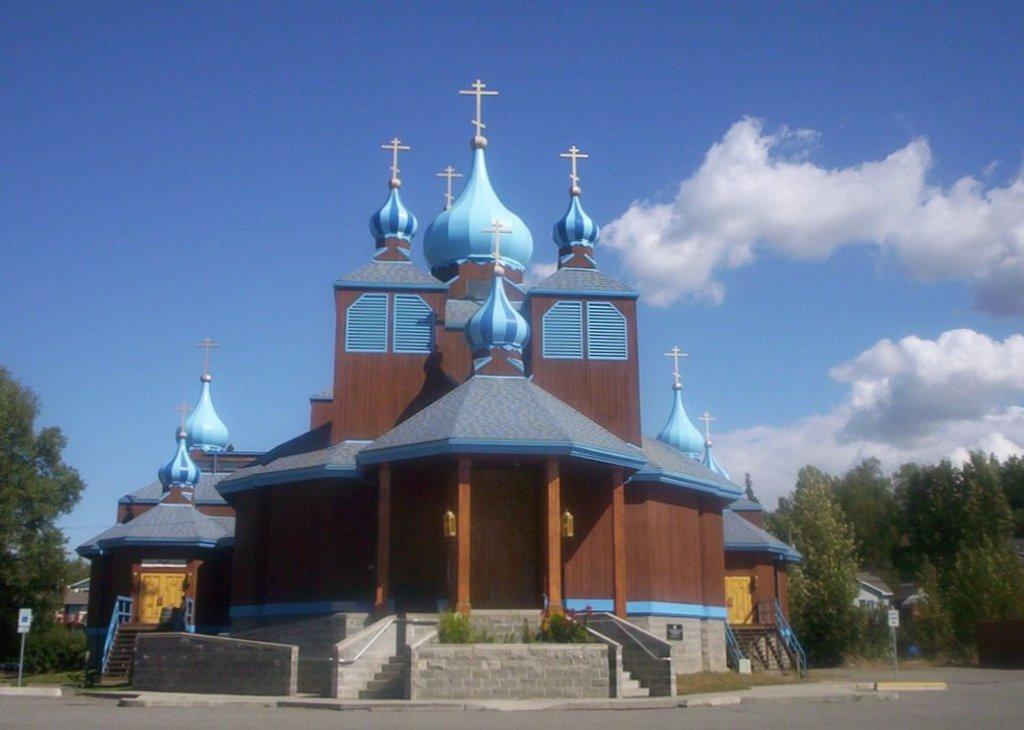What type of building is in the image? There is a church in the image. What is located in front of the church? There are stairs in front of the church. What can be seen on both sides of the church? There are trees on both sides of the church. How many beggars are sitting on the chair in front of the church? There are no chairs or beggars present in the image. 